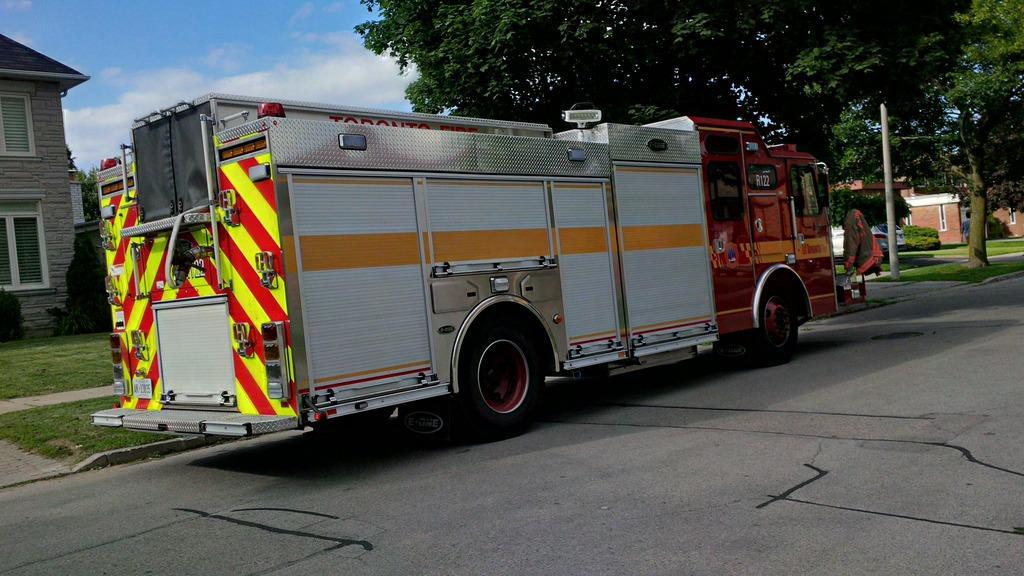Could you give a brief overview of what you see in this image? In this picture we can see fire brigade truck moving on the road. Behind we can see some trees and on the left corner there is a house. 